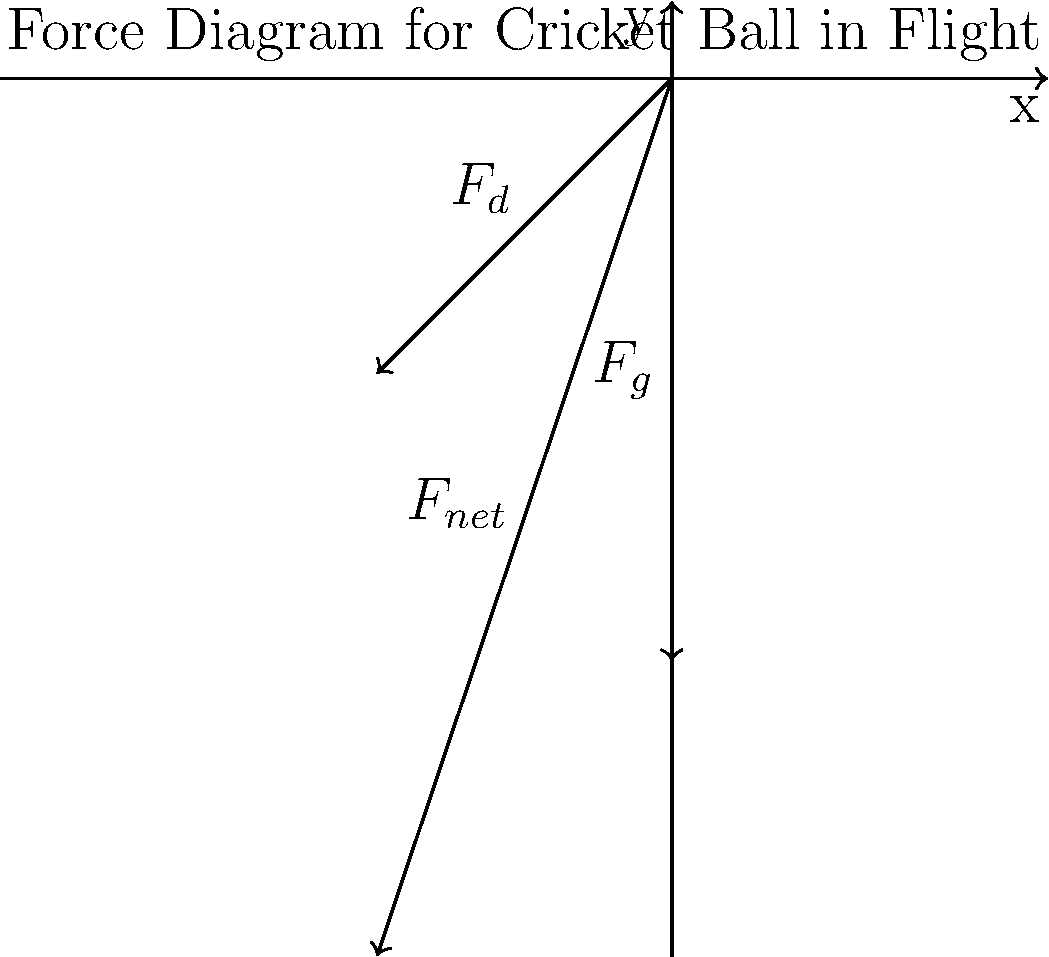A cricket ball with a mass of 0.16 kg is bowled at an initial velocity of 30 m/s at an angle of 45° to the horizontal. Given that the air density is 1.225 kg/m³ and the ball's diameter is 7.2 cm, determine the coefficient of drag ($C_d$) if the net force acting on the ball at the instant it leaves the bowler's hand is 2.2 N at an angle of 60° below the horizontal. Assume g = 9.8 m/s². Let's approach this step-by-step:

1) First, we need to identify the forces acting on the ball:
   - Weight ($F_g$): $F_g = mg = 0.16 \times 9.8 = 1.568$ N (downward)
   - Drag force ($F_d$): $F_d = \frac{1}{2} \rho v^2 C_d A$ (opposite to motion)

2) The net force is given as 2.2 N at 60° below horizontal. We can break this into components:
   $F_{net_x} = -2.2 \cos 60° = -1.1$ N
   $F_{net_y} = -2.2 \sin 60° = -1.905$ N

3) The drag force can also be broken into components:
   $F_{d_x} = -\frac{1}{2} \rho v^2 C_d A \cos 45°$
   $F_{d_y} = -\frac{1}{2} \rho v^2 C_d A \sin 45°$

4) We can now set up equations based on the net force:
   $F_{net_x} = F_{d_x} = -1.1$
   $F_{net_y} = F_g + F_{d_y} = -1.905$

5) From the x-component equation:
   $-\frac{1}{2} \rho v^2 C_d A \cos 45° = -1.1$
   $\frac{1}{2} \times 1.225 \times 30^2 \times C_d \times \pi \times (0.036)^2 \times \frac{\sqrt{2}}{2} = 1.1$

6) Solving for $C_d$:
   $C_d = \frac{1.1 \times 2}{\sqrt{2} \times 1.225 \times 30^2 \times \pi \times (0.036)^2} \approx 0.5$

7) We can verify this using the y-component equation:
   $-1.568 - \frac{1}{2} \times 1.225 \times 30^2 \times 0.5 \times \pi \times (0.036)^2 \times \frac{\sqrt{2}}{2} \approx -1.905$

The calculated value satisfies both equations, confirming our solution.
Answer: $C_d \approx 0.5$ 